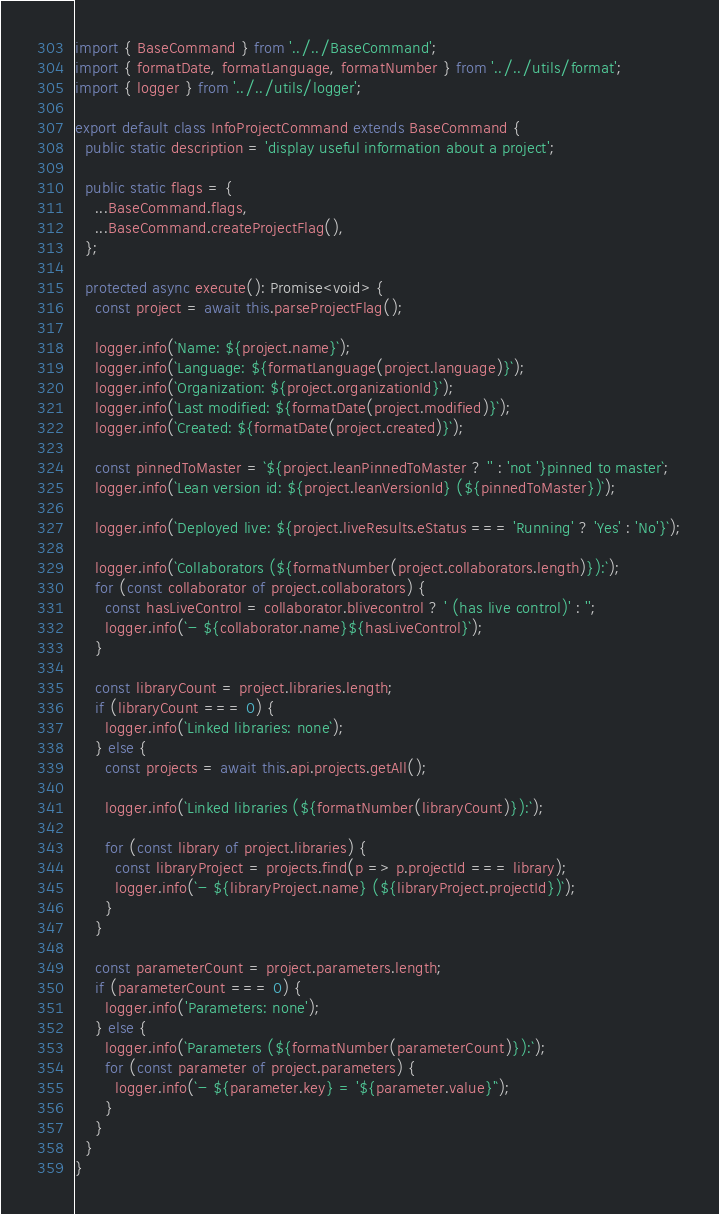Convert code to text. <code><loc_0><loc_0><loc_500><loc_500><_TypeScript_>import { BaseCommand } from '../../BaseCommand';
import { formatDate, formatLanguage, formatNumber } from '../../utils/format';
import { logger } from '../../utils/logger';

export default class InfoProjectCommand extends BaseCommand {
  public static description = 'display useful information about a project';

  public static flags = {
    ...BaseCommand.flags,
    ...BaseCommand.createProjectFlag(),
  };

  protected async execute(): Promise<void> {
    const project = await this.parseProjectFlag();

    logger.info(`Name: ${project.name}`);
    logger.info(`Language: ${formatLanguage(project.language)}`);
    logger.info(`Organization: ${project.organizationId}`);
    logger.info(`Last modified: ${formatDate(project.modified)}`);
    logger.info(`Created: ${formatDate(project.created)}`);

    const pinnedToMaster = `${project.leanPinnedToMaster ? '' : 'not '}pinned to master`;
    logger.info(`Lean version id: ${project.leanVersionId} (${pinnedToMaster})`);

    logger.info(`Deployed live: ${project.liveResults.eStatus === 'Running' ? 'Yes' : 'No'}`);

    logger.info(`Collaborators (${formatNumber(project.collaborators.length)}):`);
    for (const collaborator of project.collaborators) {
      const hasLiveControl = collaborator.blivecontrol ? ' (has live control)' : '';
      logger.info(`- ${collaborator.name}${hasLiveControl}`);
    }

    const libraryCount = project.libraries.length;
    if (libraryCount === 0) {
      logger.info(`Linked libraries: none`);
    } else {
      const projects = await this.api.projects.getAll();

      logger.info(`Linked libraries (${formatNumber(libraryCount)}):`);

      for (const library of project.libraries) {
        const libraryProject = projects.find(p => p.projectId === library);
        logger.info(`- ${libraryProject.name} (${libraryProject.projectId})`);
      }
    }

    const parameterCount = project.parameters.length;
    if (parameterCount === 0) {
      logger.info('Parameters: none');
    } else {
      logger.info(`Parameters (${formatNumber(parameterCount)}):`);
      for (const parameter of project.parameters) {
        logger.info(`- ${parameter.key} = '${parameter.value}'`);
      }
    }
  }
}
</code> 